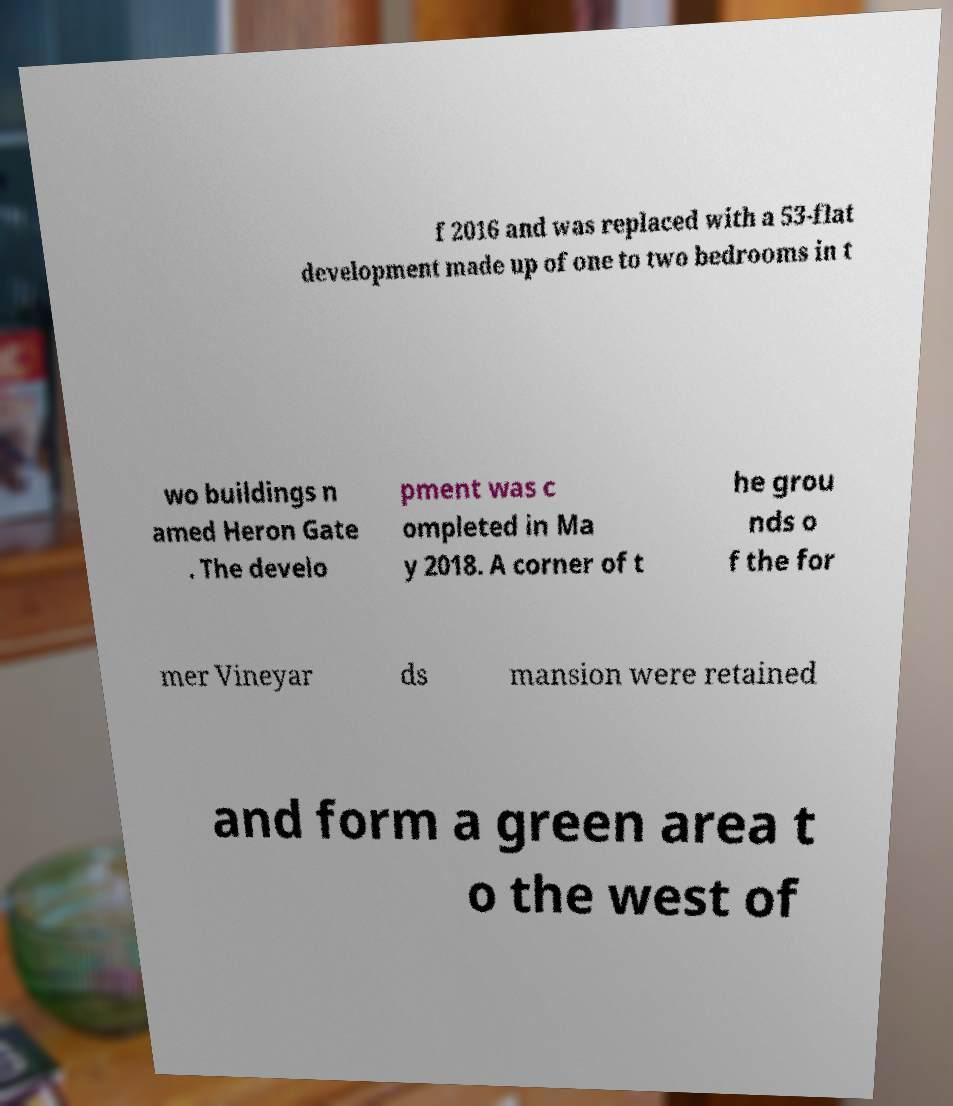I need the written content from this picture converted into text. Can you do that? f 2016 and was replaced with a 53-flat development made up of one to two bedrooms in t wo buildings n amed Heron Gate . The develo pment was c ompleted in Ma y 2018. A corner of t he grou nds o f the for mer Vineyar ds mansion were retained and form a green area t o the west of 